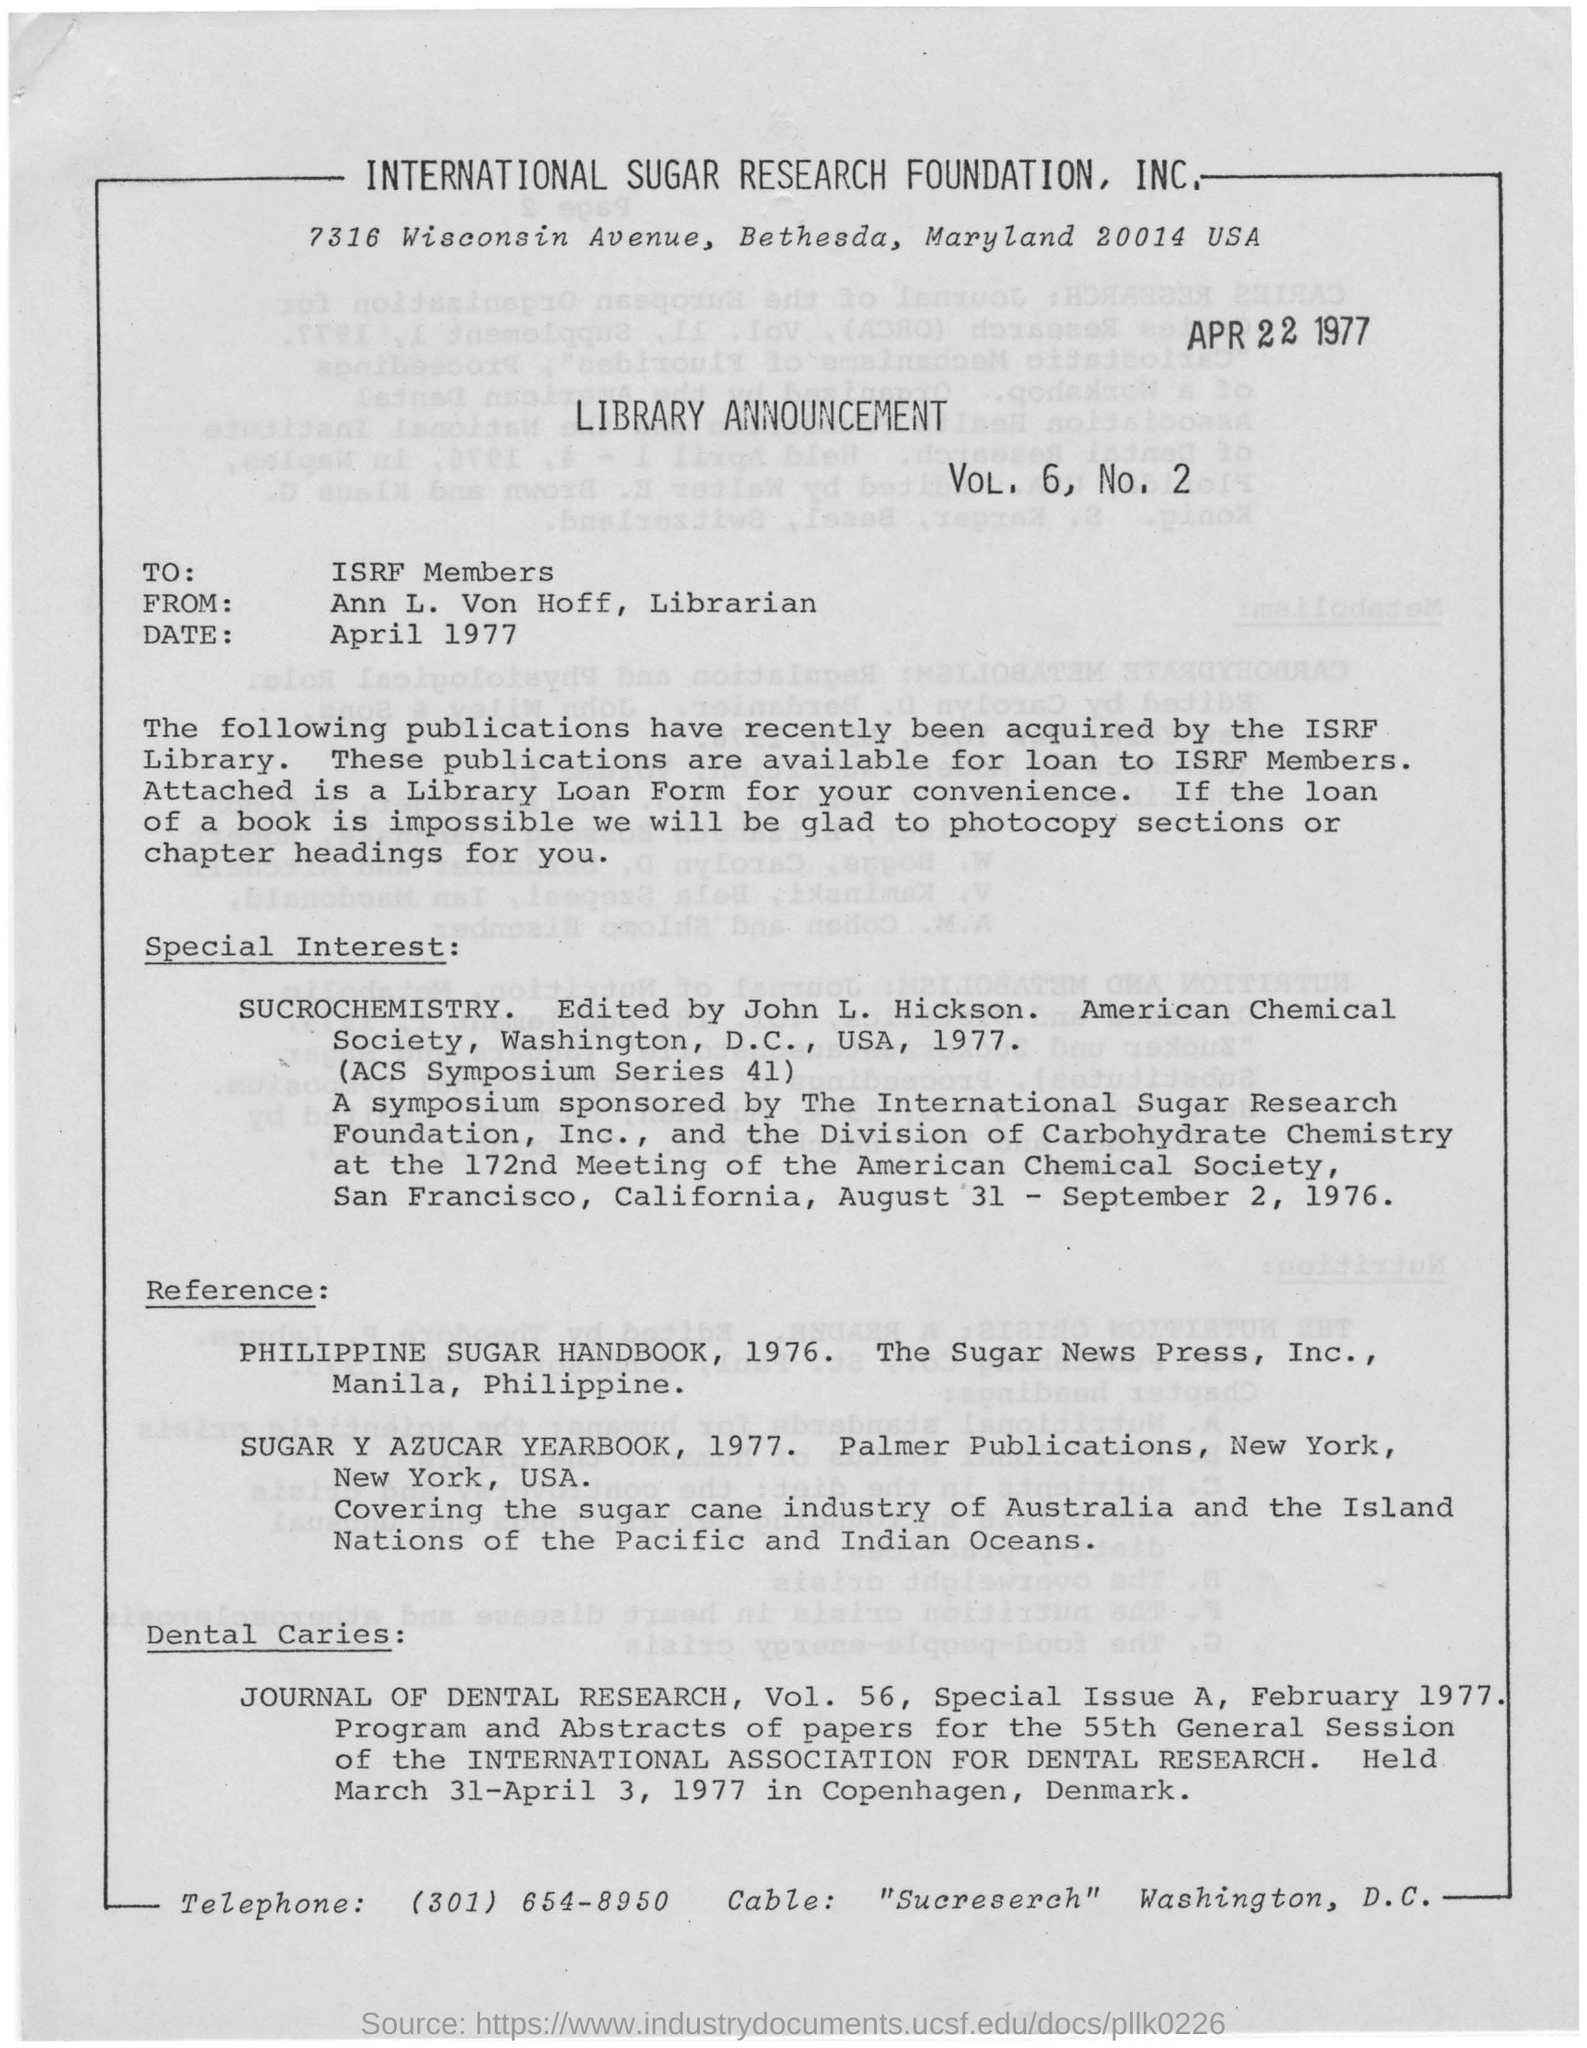Announcement is addressed to whom?
Offer a terse response. ISRF Members. Who edited the "SUCROCHEMISTRY" ?
Provide a succinct answer. John L. Hickson. What is the name of the Librarian?
Provide a short and direct response. Ann L. Von Hoff. In which country was the "INTERNATIONAL ASSOCIATION FOR DENTAL RESEARCH" held?
Make the answer very short. Copenhagen, Denmark. 